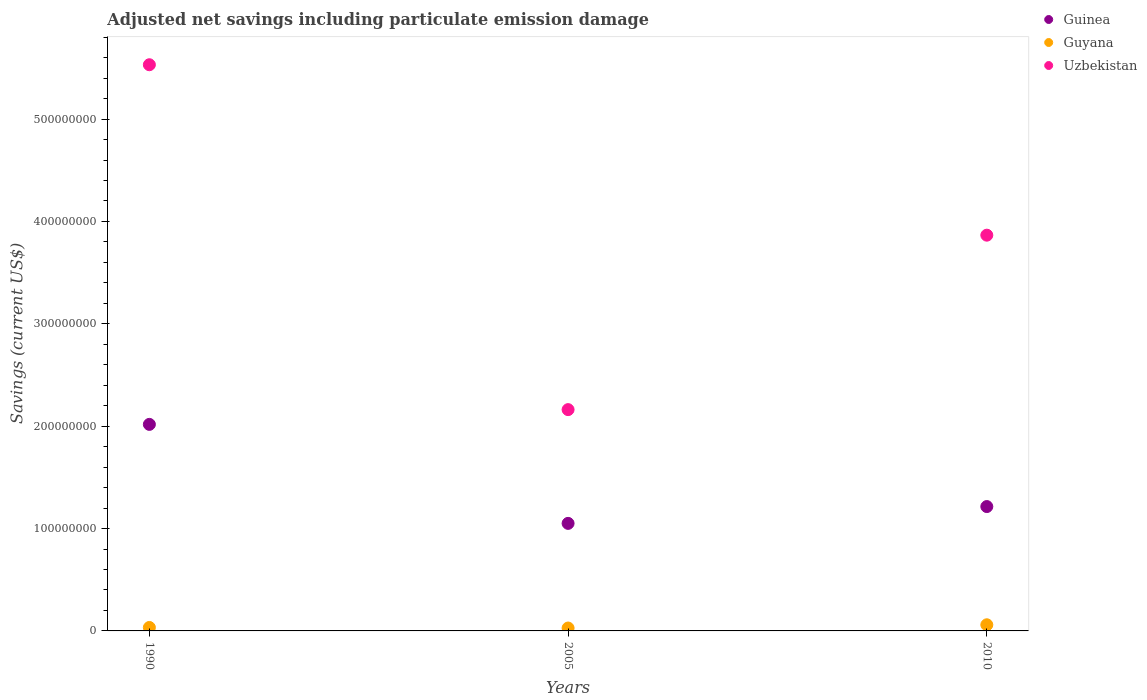How many different coloured dotlines are there?
Your answer should be compact. 3. What is the net savings in Guyana in 2005?
Offer a terse response. 2.82e+06. Across all years, what is the maximum net savings in Guyana?
Ensure brevity in your answer.  6.00e+06. Across all years, what is the minimum net savings in Uzbekistan?
Keep it short and to the point. 2.16e+08. In which year was the net savings in Uzbekistan maximum?
Provide a short and direct response. 1990. What is the total net savings in Guinea in the graph?
Give a very brief answer. 4.28e+08. What is the difference between the net savings in Guyana in 2005 and that in 2010?
Give a very brief answer. -3.17e+06. What is the difference between the net savings in Guinea in 1990 and the net savings in Uzbekistan in 2010?
Offer a terse response. -1.85e+08. What is the average net savings in Guyana per year?
Your answer should be compact. 4.07e+06. In the year 2010, what is the difference between the net savings in Uzbekistan and net savings in Guyana?
Ensure brevity in your answer.  3.81e+08. In how many years, is the net savings in Guinea greater than 220000000 US$?
Offer a very short reply. 0. What is the ratio of the net savings in Guinea in 2005 to that in 2010?
Give a very brief answer. 0.86. Is the net savings in Guinea in 2005 less than that in 2010?
Provide a short and direct response. Yes. Is the difference between the net savings in Uzbekistan in 1990 and 2005 greater than the difference between the net savings in Guyana in 1990 and 2005?
Your response must be concise. Yes. What is the difference between the highest and the second highest net savings in Guyana?
Ensure brevity in your answer.  2.62e+06. What is the difference between the highest and the lowest net savings in Guyana?
Your answer should be compact. 3.17e+06. How many dotlines are there?
Make the answer very short. 3. How many years are there in the graph?
Provide a short and direct response. 3. What is the difference between two consecutive major ticks on the Y-axis?
Provide a short and direct response. 1.00e+08. How many legend labels are there?
Provide a short and direct response. 3. What is the title of the graph?
Provide a short and direct response. Adjusted net savings including particulate emission damage. What is the label or title of the X-axis?
Offer a terse response. Years. What is the label or title of the Y-axis?
Your answer should be compact. Savings (current US$). What is the Savings (current US$) of Guinea in 1990?
Offer a very short reply. 2.02e+08. What is the Savings (current US$) in Guyana in 1990?
Your response must be concise. 3.37e+06. What is the Savings (current US$) of Uzbekistan in 1990?
Make the answer very short. 5.53e+08. What is the Savings (current US$) of Guinea in 2005?
Your response must be concise. 1.05e+08. What is the Savings (current US$) of Guyana in 2005?
Offer a terse response. 2.82e+06. What is the Savings (current US$) in Uzbekistan in 2005?
Provide a short and direct response. 2.16e+08. What is the Savings (current US$) in Guinea in 2010?
Make the answer very short. 1.21e+08. What is the Savings (current US$) in Guyana in 2010?
Give a very brief answer. 6.00e+06. What is the Savings (current US$) of Uzbekistan in 2010?
Your answer should be compact. 3.87e+08. Across all years, what is the maximum Savings (current US$) in Guinea?
Ensure brevity in your answer.  2.02e+08. Across all years, what is the maximum Savings (current US$) in Guyana?
Your response must be concise. 6.00e+06. Across all years, what is the maximum Savings (current US$) in Uzbekistan?
Your answer should be compact. 5.53e+08. Across all years, what is the minimum Savings (current US$) of Guinea?
Provide a short and direct response. 1.05e+08. Across all years, what is the minimum Savings (current US$) of Guyana?
Offer a terse response. 2.82e+06. Across all years, what is the minimum Savings (current US$) in Uzbekistan?
Keep it short and to the point. 2.16e+08. What is the total Savings (current US$) in Guinea in the graph?
Provide a succinct answer. 4.28e+08. What is the total Savings (current US$) in Guyana in the graph?
Give a very brief answer. 1.22e+07. What is the total Savings (current US$) in Uzbekistan in the graph?
Make the answer very short. 1.16e+09. What is the difference between the Savings (current US$) in Guinea in 1990 and that in 2005?
Make the answer very short. 9.67e+07. What is the difference between the Savings (current US$) of Guyana in 1990 and that in 2005?
Give a very brief answer. 5.50e+05. What is the difference between the Savings (current US$) of Uzbekistan in 1990 and that in 2005?
Make the answer very short. 3.37e+08. What is the difference between the Savings (current US$) in Guinea in 1990 and that in 2010?
Provide a succinct answer. 8.03e+07. What is the difference between the Savings (current US$) in Guyana in 1990 and that in 2010?
Provide a succinct answer. -2.62e+06. What is the difference between the Savings (current US$) in Uzbekistan in 1990 and that in 2010?
Offer a terse response. 1.66e+08. What is the difference between the Savings (current US$) in Guinea in 2005 and that in 2010?
Make the answer very short. -1.64e+07. What is the difference between the Savings (current US$) of Guyana in 2005 and that in 2010?
Offer a very short reply. -3.17e+06. What is the difference between the Savings (current US$) of Uzbekistan in 2005 and that in 2010?
Offer a terse response. -1.70e+08. What is the difference between the Savings (current US$) in Guinea in 1990 and the Savings (current US$) in Guyana in 2005?
Your response must be concise. 1.99e+08. What is the difference between the Savings (current US$) of Guinea in 1990 and the Savings (current US$) of Uzbekistan in 2005?
Your answer should be very brief. -1.44e+07. What is the difference between the Savings (current US$) in Guyana in 1990 and the Savings (current US$) in Uzbekistan in 2005?
Your answer should be compact. -2.13e+08. What is the difference between the Savings (current US$) in Guinea in 1990 and the Savings (current US$) in Guyana in 2010?
Make the answer very short. 1.96e+08. What is the difference between the Savings (current US$) of Guinea in 1990 and the Savings (current US$) of Uzbekistan in 2010?
Make the answer very short. -1.85e+08. What is the difference between the Savings (current US$) in Guyana in 1990 and the Savings (current US$) in Uzbekistan in 2010?
Your response must be concise. -3.83e+08. What is the difference between the Savings (current US$) of Guinea in 2005 and the Savings (current US$) of Guyana in 2010?
Give a very brief answer. 9.91e+07. What is the difference between the Savings (current US$) in Guinea in 2005 and the Savings (current US$) in Uzbekistan in 2010?
Your answer should be compact. -2.82e+08. What is the difference between the Savings (current US$) of Guyana in 2005 and the Savings (current US$) of Uzbekistan in 2010?
Your answer should be very brief. -3.84e+08. What is the average Savings (current US$) of Guinea per year?
Offer a very short reply. 1.43e+08. What is the average Savings (current US$) of Guyana per year?
Offer a very short reply. 4.07e+06. What is the average Savings (current US$) of Uzbekistan per year?
Provide a short and direct response. 3.85e+08. In the year 1990, what is the difference between the Savings (current US$) of Guinea and Savings (current US$) of Guyana?
Your answer should be very brief. 1.98e+08. In the year 1990, what is the difference between the Savings (current US$) in Guinea and Savings (current US$) in Uzbekistan?
Your response must be concise. -3.51e+08. In the year 1990, what is the difference between the Savings (current US$) of Guyana and Savings (current US$) of Uzbekistan?
Provide a short and direct response. -5.50e+08. In the year 2005, what is the difference between the Savings (current US$) in Guinea and Savings (current US$) in Guyana?
Provide a succinct answer. 1.02e+08. In the year 2005, what is the difference between the Savings (current US$) in Guinea and Savings (current US$) in Uzbekistan?
Give a very brief answer. -1.11e+08. In the year 2005, what is the difference between the Savings (current US$) of Guyana and Savings (current US$) of Uzbekistan?
Provide a short and direct response. -2.13e+08. In the year 2010, what is the difference between the Savings (current US$) of Guinea and Savings (current US$) of Guyana?
Ensure brevity in your answer.  1.15e+08. In the year 2010, what is the difference between the Savings (current US$) in Guinea and Savings (current US$) in Uzbekistan?
Keep it short and to the point. -2.65e+08. In the year 2010, what is the difference between the Savings (current US$) of Guyana and Savings (current US$) of Uzbekistan?
Offer a very short reply. -3.81e+08. What is the ratio of the Savings (current US$) of Guinea in 1990 to that in 2005?
Your answer should be very brief. 1.92. What is the ratio of the Savings (current US$) in Guyana in 1990 to that in 2005?
Keep it short and to the point. 1.19. What is the ratio of the Savings (current US$) of Uzbekistan in 1990 to that in 2005?
Offer a very short reply. 2.56. What is the ratio of the Savings (current US$) of Guinea in 1990 to that in 2010?
Offer a very short reply. 1.66. What is the ratio of the Savings (current US$) in Guyana in 1990 to that in 2010?
Your answer should be compact. 0.56. What is the ratio of the Savings (current US$) in Uzbekistan in 1990 to that in 2010?
Keep it short and to the point. 1.43. What is the ratio of the Savings (current US$) of Guinea in 2005 to that in 2010?
Keep it short and to the point. 0.86. What is the ratio of the Savings (current US$) of Guyana in 2005 to that in 2010?
Your answer should be very brief. 0.47. What is the ratio of the Savings (current US$) in Uzbekistan in 2005 to that in 2010?
Give a very brief answer. 0.56. What is the difference between the highest and the second highest Savings (current US$) in Guinea?
Provide a short and direct response. 8.03e+07. What is the difference between the highest and the second highest Savings (current US$) of Guyana?
Your answer should be very brief. 2.62e+06. What is the difference between the highest and the second highest Savings (current US$) of Uzbekistan?
Make the answer very short. 1.66e+08. What is the difference between the highest and the lowest Savings (current US$) in Guinea?
Offer a very short reply. 9.67e+07. What is the difference between the highest and the lowest Savings (current US$) of Guyana?
Ensure brevity in your answer.  3.17e+06. What is the difference between the highest and the lowest Savings (current US$) in Uzbekistan?
Your response must be concise. 3.37e+08. 